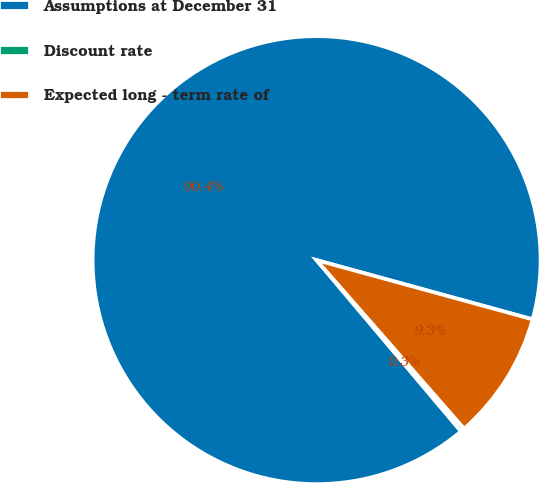Convert chart. <chart><loc_0><loc_0><loc_500><loc_500><pie_chart><fcel>Assumptions at December 31<fcel>Discount rate<fcel>Expected long - term rate of<nl><fcel>90.41%<fcel>0.29%<fcel>9.3%<nl></chart> 